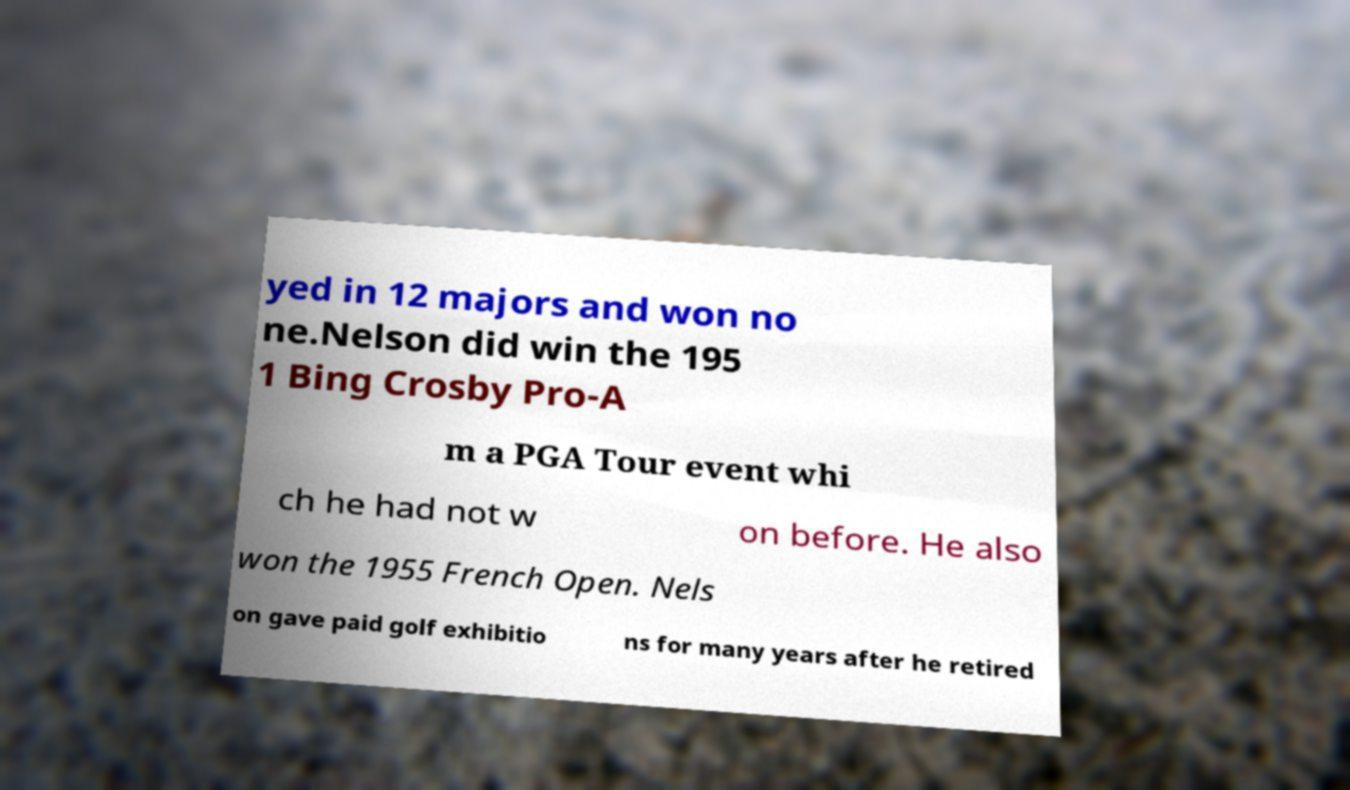Can you read and provide the text displayed in the image?This photo seems to have some interesting text. Can you extract and type it out for me? yed in 12 majors and won no ne.Nelson did win the 195 1 Bing Crosby Pro-A m a PGA Tour event whi ch he had not w on before. He also won the 1955 French Open. Nels on gave paid golf exhibitio ns for many years after he retired 